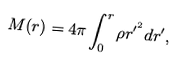<formula> <loc_0><loc_0><loc_500><loc_500>M ( r ) = 4 \pi \int ^ { r } _ { 0 } \rho r ^ { \prime ^ { 2 } } d r ^ { \prime } ,</formula> 